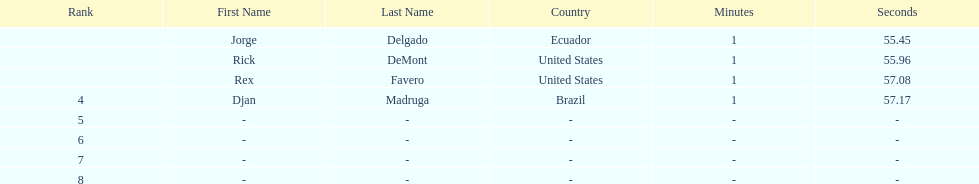What come after rex f. Djan Madruga. Can you give me this table as a dict? {'header': ['Rank', 'First Name', 'Last Name', 'Country', 'Minutes', 'Seconds'], 'rows': [['', 'Jorge', 'Delgado', 'Ecuador', '1', '55.45'], ['', 'Rick', 'DeMont', 'United States', '1', '55.96'], ['', 'Rex', 'Favero', 'United States', '1', '57.08'], ['4', 'Djan', 'Madruga', 'Brazil', '1', '57.17'], ['5', '-', '-', '-', '-', '-'], ['6', '-', '-', '-', '-', '-'], ['7', '-', '-', '-', '-', '-'], ['8', '-', '-', '-', '-', '-']]} 